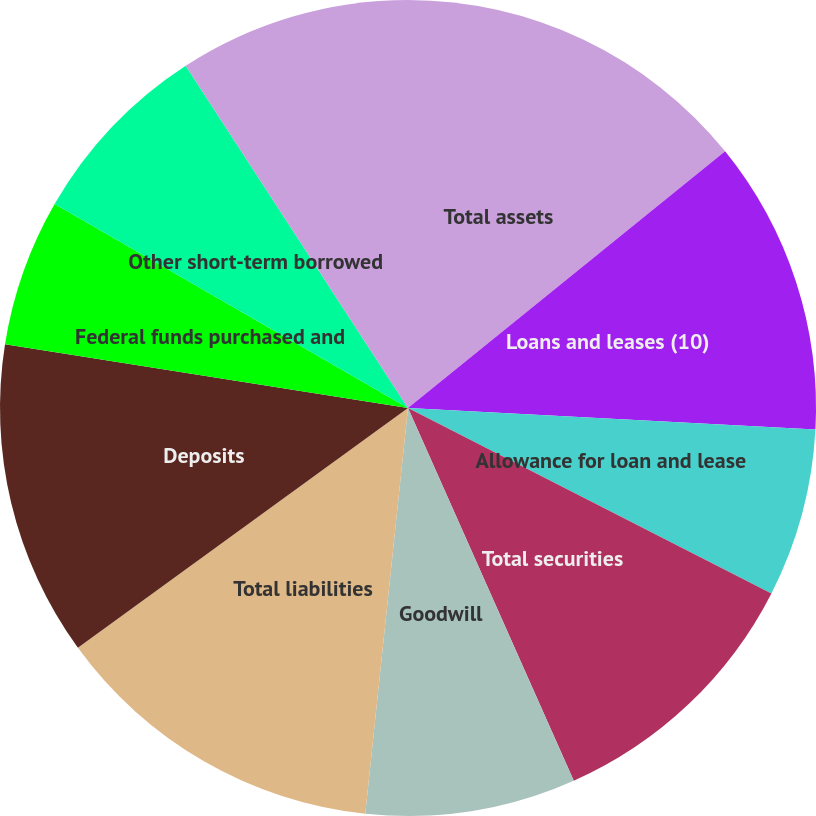Convert chart. <chart><loc_0><loc_0><loc_500><loc_500><pie_chart><fcel>Total assets<fcel>Loans and leases (10)<fcel>Allowance for loan and lease<fcel>Total securities<fcel>Goodwill<fcel>Total liabilities<fcel>Deposits<fcel>Federal funds purchased and<fcel>Other short-term borrowed<fcel>Long-term borrowed funds<nl><fcel>14.17%<fcel>11.67%<fcel>6.67%<fcel>10.83%<fcel>8.33%<fcel>13.33%<fcel>12.5%<fcel>5.83%<fcel>7.5%<fcel>9.17%<nl></chart> 